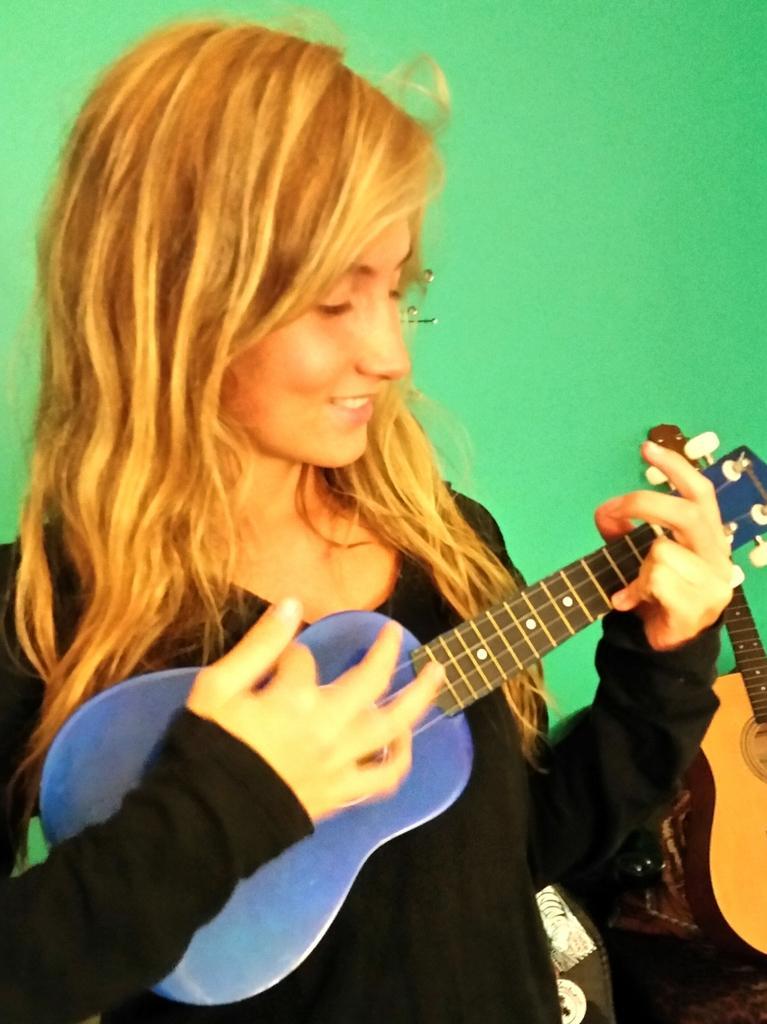Can you describe this image briefly? In this image a woman is standing and holding a musical instrument in her hand and is having smile on her face. In the background there is a green colour wall. 